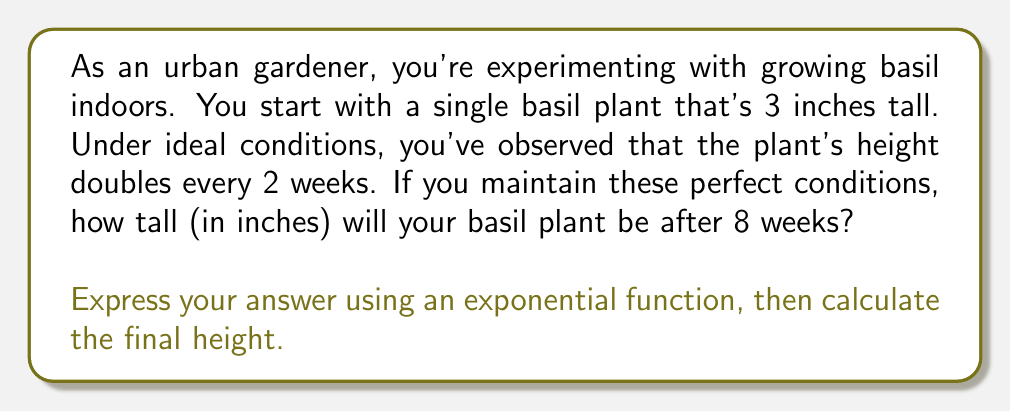What is the answer to this math problem? Let's approach this step-by-step:

1) First, we need to identify the components of our exponential function:
   - Initial height: 3 inches
   - Growth rate: doubles (multiplies by 2) every 2 weeks
   - Time period: 8 weeks

2) The general form of an exponential growth function is:
   $$ H(t) = H_0 \cdot b^{t/p} $$
   Where:
   $H(t)$ is the height at time $t$
   $H_0$ is the initial height
   $b$ is the growth factor
   $t$ is the time elapsed
   $p$ is the time period for each growth cycle

3) In our case:
   $H_0 = 3$ (initial height)
   $b = 2$ (doubles each cycle)
   $t = 8$ (total weeks)
   $p = 2$ (weeks per cycle)

4) Plugging these into our function:
   $$ H(8) = 3 \cdot 2^{8/2} $$

5) Simplify the exponent:
   $$ H(8) = 3 \cdot 2^4 $$

6) Calculate $2^4$:
   $$ H(8) = 3 \cdot 16 $$

7) Multiply:
   $$ H(8) = 48 $$

Therefore, after 8 weeks, the basil plant will be 48 inches tall.
Answer: The height of the basil plant after 8 weeks can be expressed as:
$$ H(8) = 3 \cdot 2^{8/2} = 48 \text{ inches} $$ 